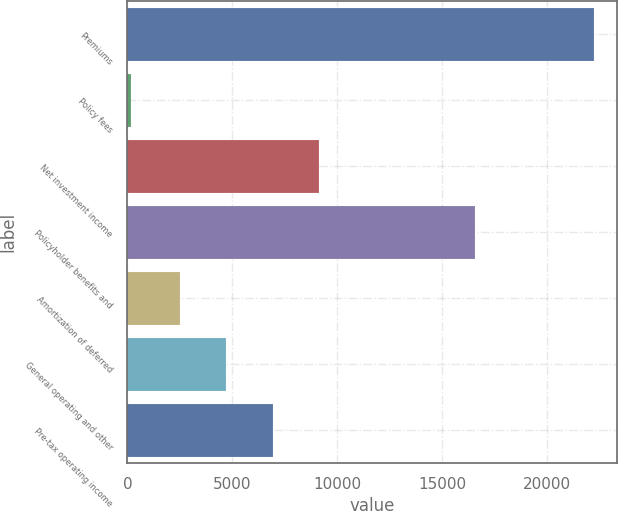<chart> <loc_0><loc_0><loc_500><loc_500><bar_chart><fcel>Premiums<fcel>Policy fees<fcel>Net investment income<fcel>Policyholder benefits and<fcel>Amortization of deferred<fcel>General operating and other<fcel>Pre-tax operating income<nl><fcel>22221<fcel>187<fcel>9122.2<fcel>16575<fcel>2512<fcel>4715.4<fcel>6918.8<nl></chart> 